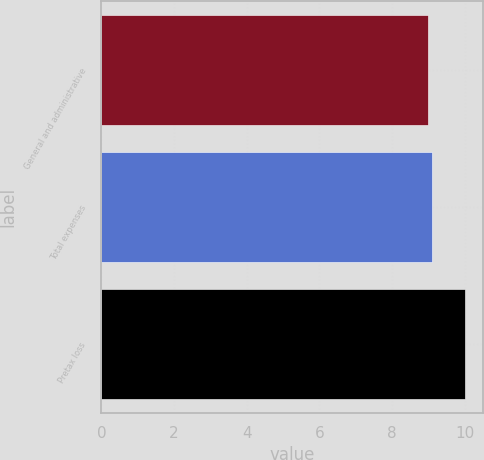Convert chart. <chart><loc_0><loc_0><loc_500><loc_500><bar_chart><fcel>General and administrative<fcel>Total expenses<fcel>Pretax loss<nl><fcel>9<fcel>9.1<fcel>10<nl></chart> 